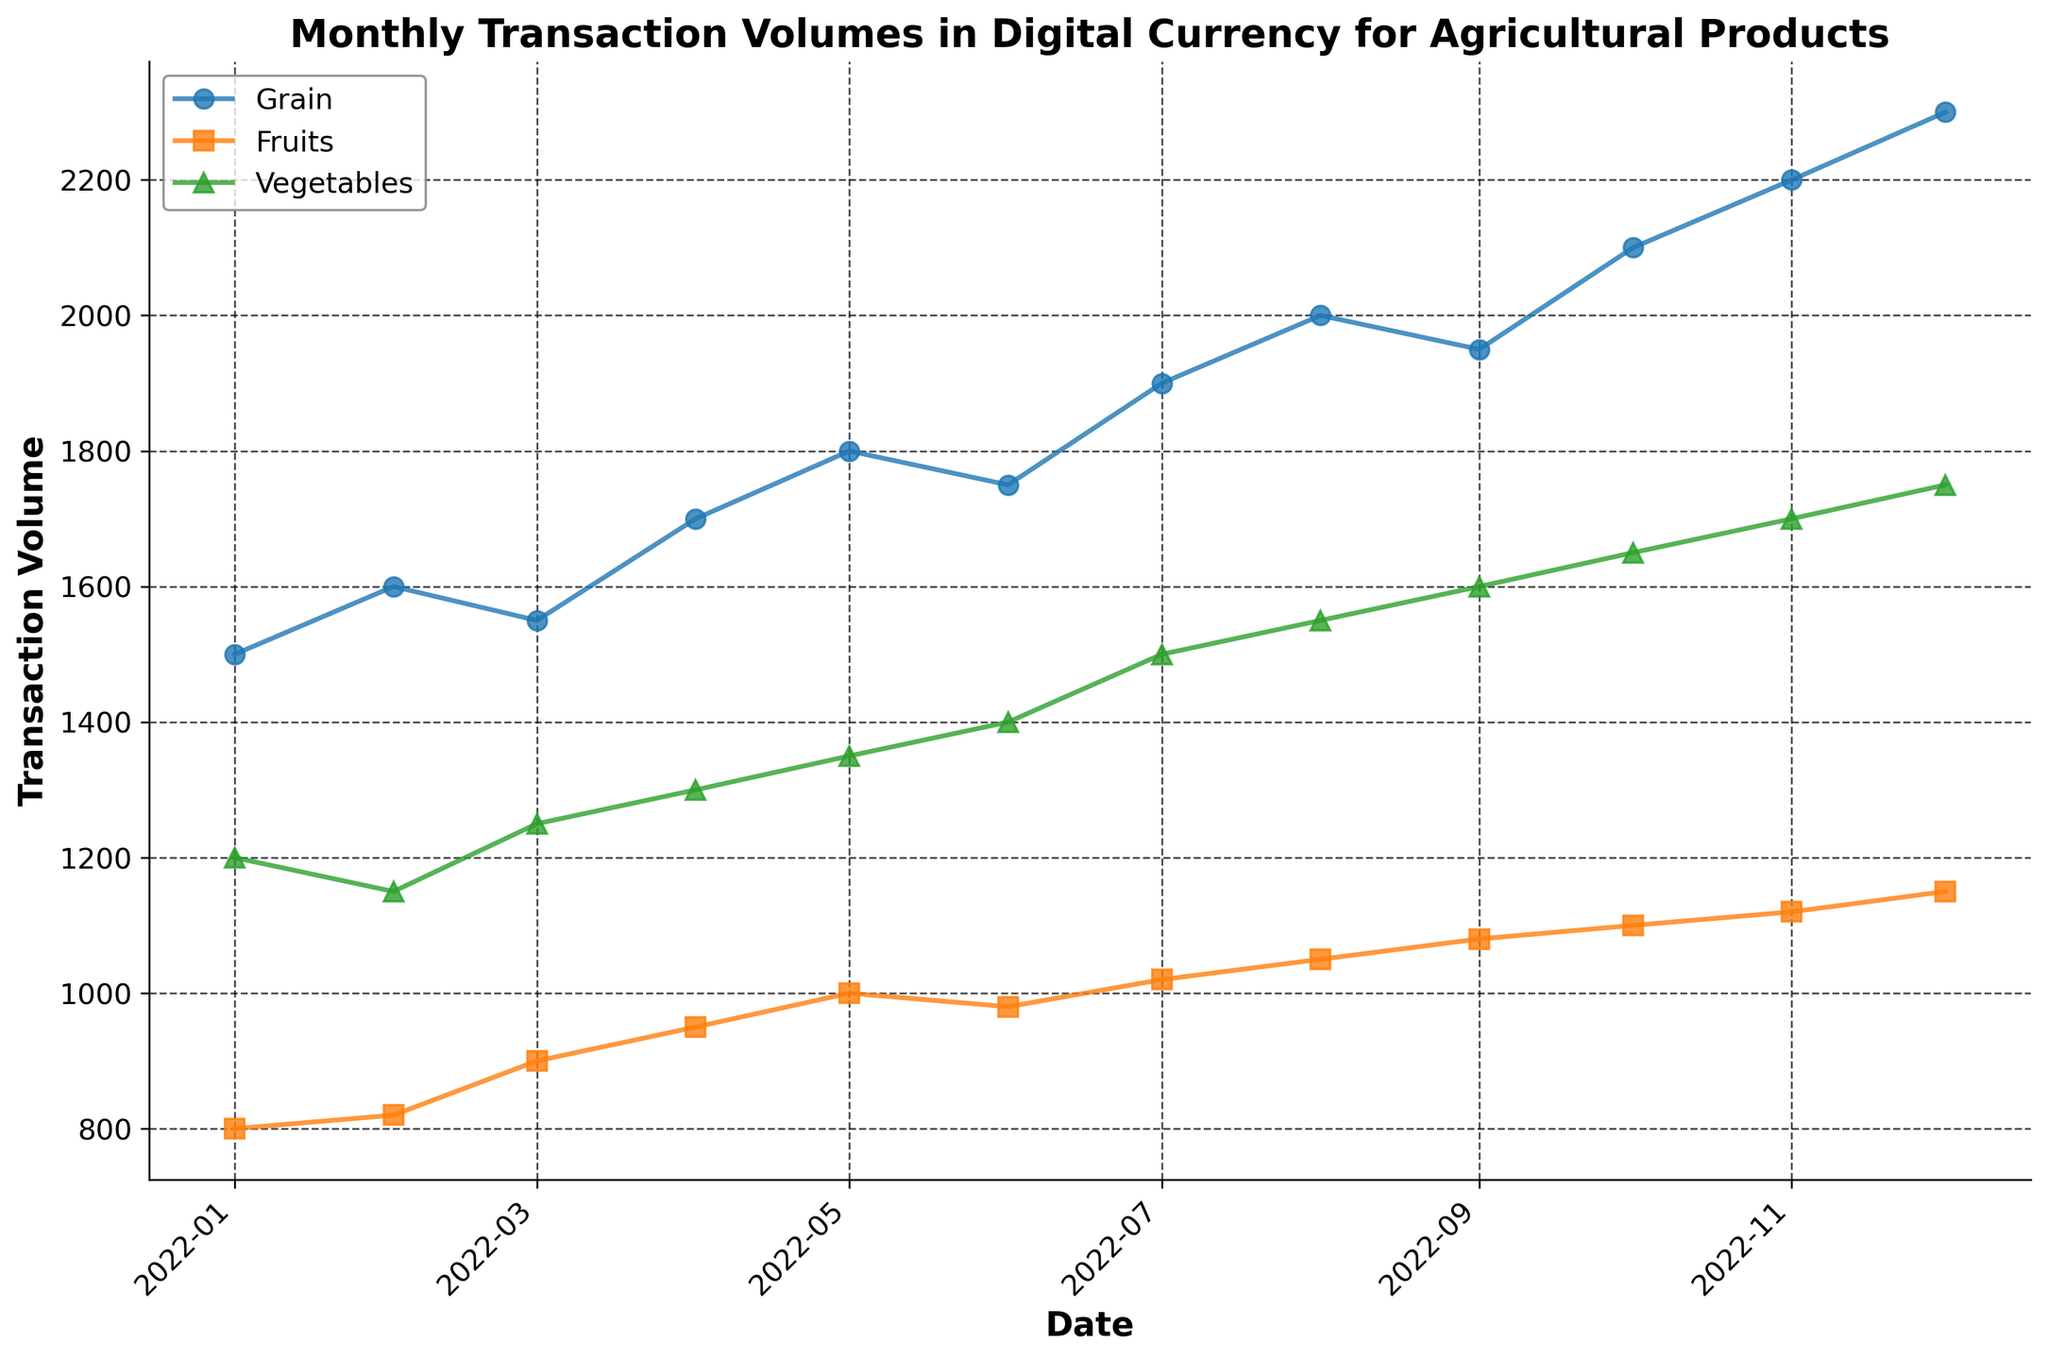What is the title of the figure? The title is usually displayed at the top of the figure in a larger or bold font. For this figure, it is shown at the top and reads "Monthly Transaction Volumes in Digital Currency for Agricultural Products."
Answer: Monthly Transaction Volumes in Digital Currency for Agricultural Products What products are displayed in the figure? By examining the legend, which typically lists the items being plotted with their respective colors or markers, we can identify the products. Here, they are listed as: Grain, Fruits, and Vegetables.
Answer: Grain, Fruits, Vegetables Which product had the highest transaction volume in December 2022? Locate the December 2022 data points on the x-axis and observe which line has the highest y-axis value. For December 2022, the transaction volume for Grain is the highest.
Answer: Grain How does the transaction volume for Fruits change from January 2022 to December 2022? Follow the line for Fruits from the left (January 2022) to the right (December 2022). Observe the trend: it starts at 800 and gradually increases to 1150 over the months.
Answer: Increases from 800 to 1150 What month had the peak transaction volume for Vegetables? Trace the line for Vegetables and identify the point where it reaches the highest vertical position on the y-axis. The peak occurs in December 2022, with a volume of 1750.
Answer: December 2022 How does the trend for Grain transaction volume from July 2022 to September 2022 compare to the trend for Vegetables in the same period? Analyze both lines in the relevant months. Grain transaction volumes increase (1900 to 1950), whereas Vegetables also increase (1500 to 1600). Both show an upward trend.
Answer: Both increase What is the total transaction volume for Fruits from January to December 2022? Sum the monthly volumes for Fruits (800 + 820 + 900 + 950 + 1000 + 980 + 1020 + 1050 + 1080 + 1100 + 1120 + 1150). The computation results in 11470.
Answer: 11470 Which product shows the most consistent increase in transaction volume throughout the year 2022? Compare the trends of the three lines in the figure to determine consistency. Fruits have a relatively steady upward trend without noticeable declines.
Answer: Fruits What was the percentage increase in the transaction volume for Grain from January 2022 to December 2022? Calculate the percentage change from January (1500) to December (2300). The formula is ((2300 - 1500) / 1500) * 100 = 53.33%.
Answer: 53.33% Compare the transaction volume in November 2022 for Fruits and Vegetables. Which product had a higher volume and by how much? Observe the data points for November 2022. Fruits had 1120; Vegetables had 1700. The difference is 1700 - 1120 = 580.
Answer: Vegetables by 580 